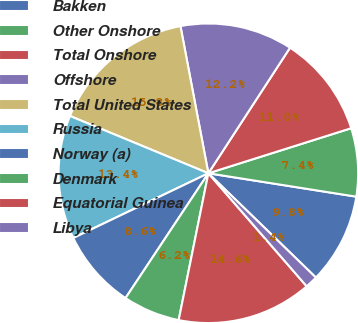Convert chart. <chart><loc_0><loc_0><loc_500><loc_500><pie_chart><fcel>Bakken<fcel>Other Onshore<fcel>Total Onshore<fcel>Offshore<fcel>Total United States<fcel>Russia<fcel>Norway (a)<fcel>Denmark<fcel>Equatorial Guinea<fcel>Libya<nl><fcel>9.76%<fcel>7.36%<fcel>10.96%<fcel>12.16%<fcel>15.77%<fcel>13.36%<fcel>8.56%<fcel>6.15%<fcel>14.57%<fcel>1.35%<nl></chart> 